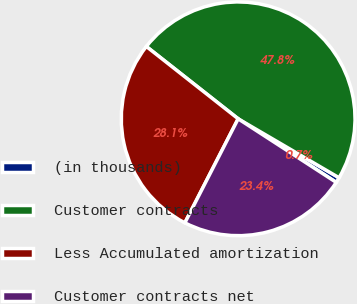<chart> <loc_0><loc_0><loc_500><loc_500><pie_chart><fcel>(in thousands)<fcel>Customer contracts<fcel>Less Accumulated amortization<fcel>Customer contracts net<nl><fcel>0.74%<fcel>47.79%<fcel>28.08%<fcel>23.38%<nl></chart> 